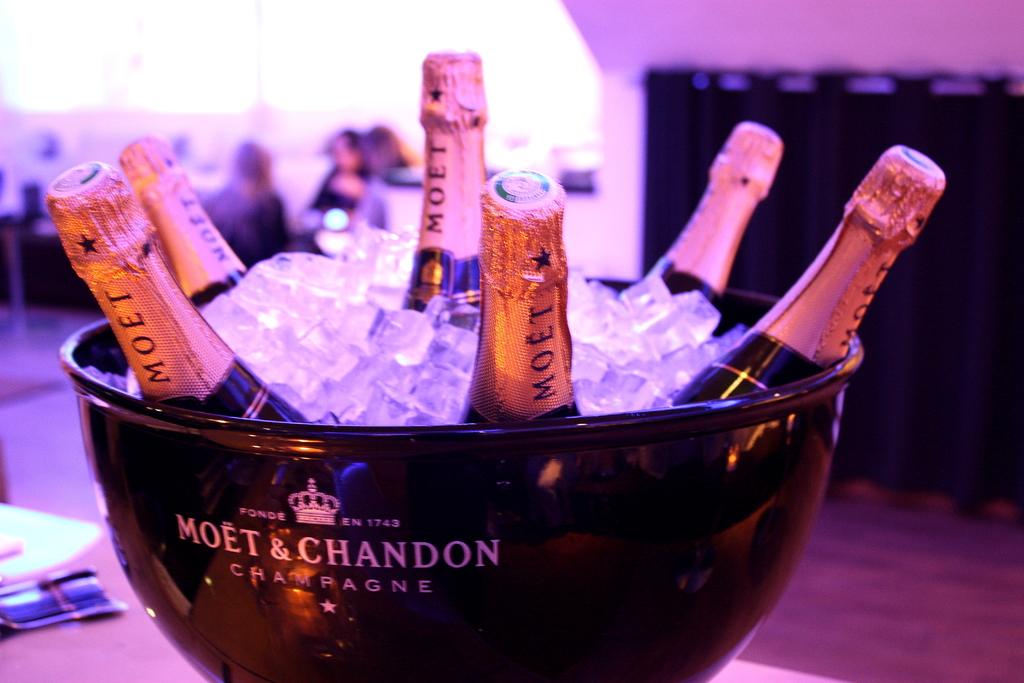What year was the company founded?
Provide a short and direct response. 1743. 